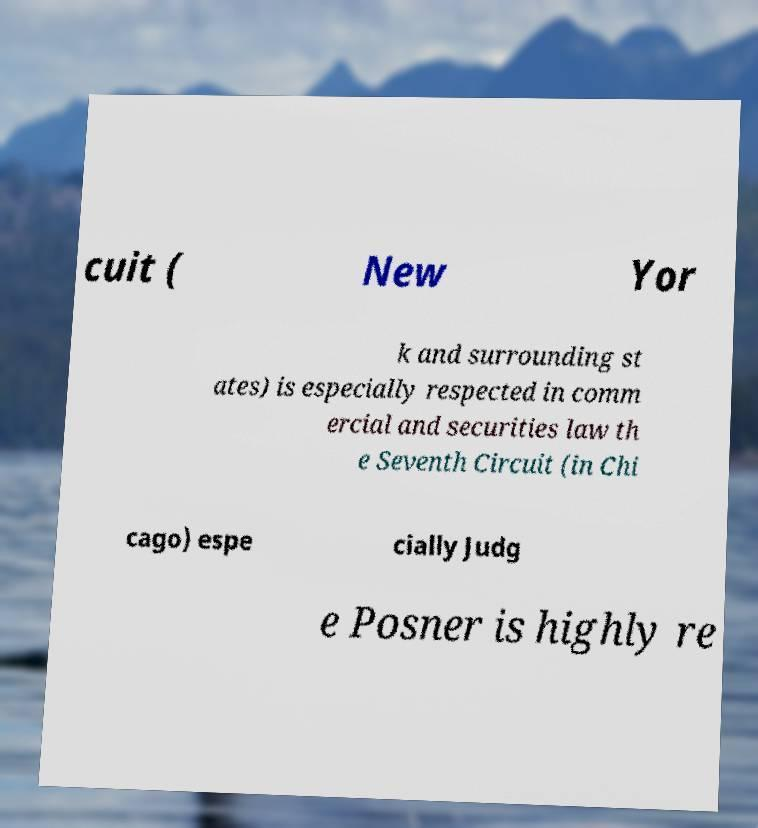Can you read and provide the text displayed in the image?This photo seems to have some interesting text. Can you extract and type it out for me? cuit ( New Yor k and surrounding st ates) is especially respected in comm ercial and securities law th e Seventh Circuit (in Chi cago) espe cially Judg e Posner is highly re 